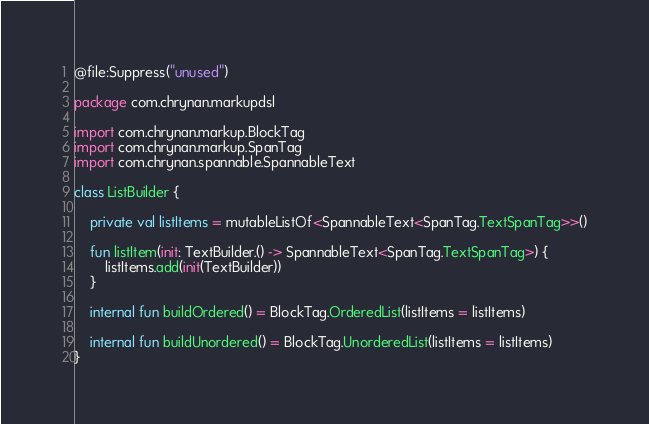Convert code to text. <code><loc_0><loc_0><loc_500><loc_500><_Kotlin_>@file:Suppress("unused")

package com.chrynan.markupdsl

import com.chrynan.markup.BlockTag
import com.chrynan.markup.SpanTag
import com.chrynan.spannable.SpannableText

class ListBuilder {

    private val listItems = mutableListOf<SpannableText<SpanTag.TextSpanTag>>()

    fun listItem(init: TextBuilder.() -> SpannableText<SpanTag.TextSpanTag>) {
        listItems.add(init(TextBuilder))
    }

    internal fun buildOrdered() = BlockTag.OrderedList(listItems = listItems)

    internal fun buildUnordered() = BlockTag.UnorderedList(listItems = listItems)
}</code> 